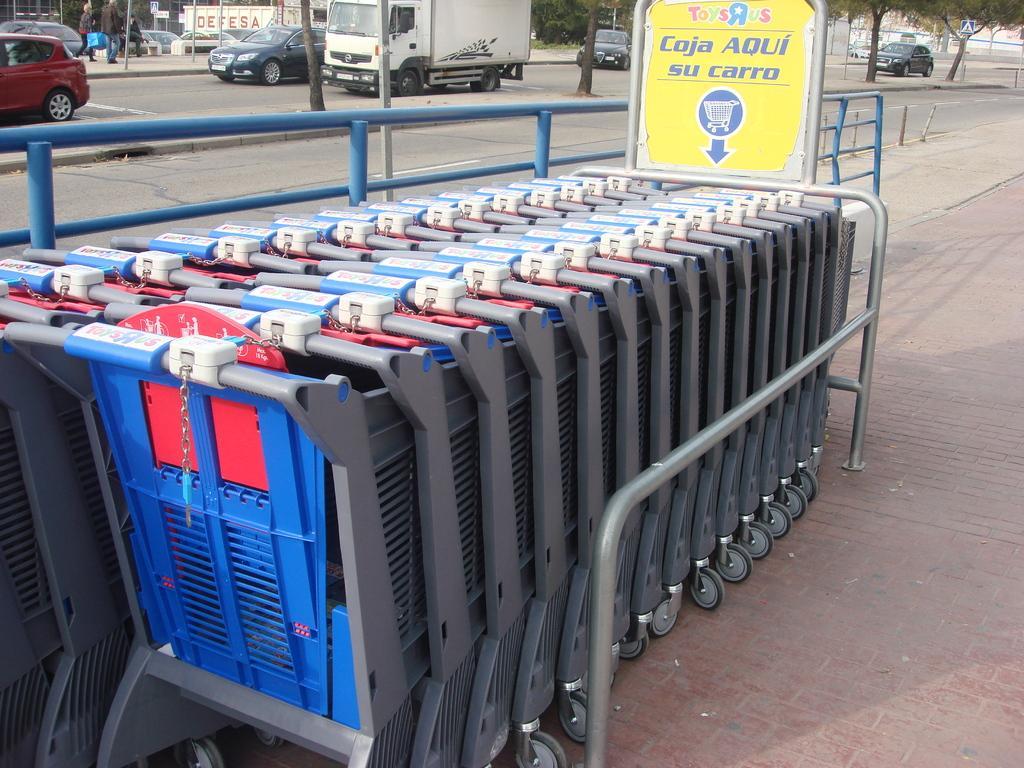Describe this image in one or two sentences. In this image in the center there are some trolleys, boards, railing. And in the background there are some trees, vehicles and some persons. At the bottom there is road. 